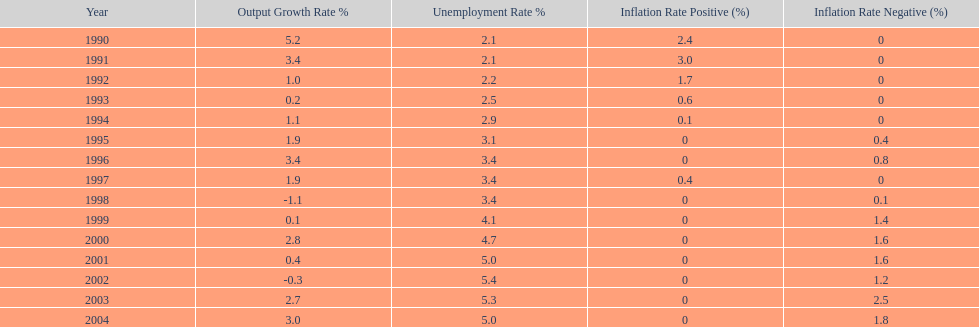Were the highest unemployment rates in japan before or after the year 2000? After. 